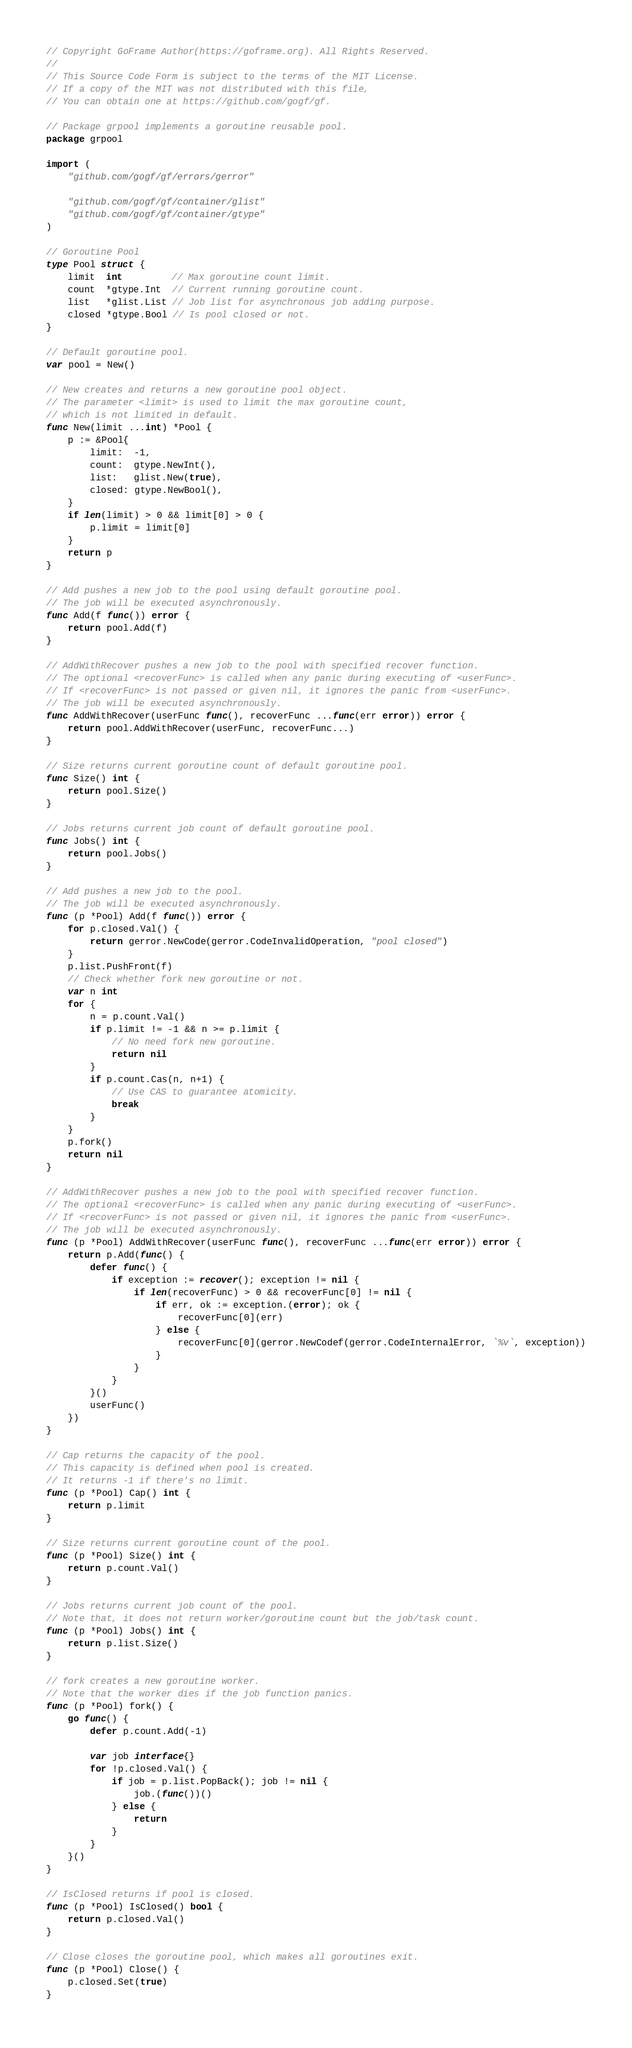Convert code to text. <code><loc_0><loc_0><loc_500><loc_500><_Go_>// Copyright GoFrame Author(https://goframe.org). All Rights Reserved.
//
// This Source Code Form is subject to the terms of the MIT License.
// If a copy of the MIT was not distributed with this file,
// You can obtain one at https://github.com/gogf/gf.

// Package grpool implements a goroutine reusable pool.
package grpool

import (
	"github.com/gogf/gf/errors/gerror"

	"github.com/gogf/gf/container/glist"
	"github.com/gogf/gf/container/gtype"
)

// Goroutine Pool
type Pool struct {
	limit  int         // Max goroutine count limit.
	count  *gtype.Int  // Current running goroutine count.
	list   *glist.List // Job list for asynchronous job adding purpose.
	closed *gtype.Bool // Is pool closed or not.
}

// Default goroutine pool.
var pool = New()

// New creates and returns a new goroutine pool object.
// The parameter <limit> is used to limit the max goroutine count,
// which is not limited in default.
func New(limit ...int) *Pool {
	p := &Pool{
		limit:  -1,
		count:  gtype.NewInt(),
		list:   glist.New(true),
		closed: gtype.NewBool(),
	}
	if len(limit) > 0 && limit[0] > 0 {
		p.limit = limit[0]
	}
	return p
}

// Add pushes a new job to the pool using default goroutine pool.
// The job will be executed asynchronously.
func Add(f func()) error {
	return pool.Add(f)
}

// AddWithRecover pushes a new job to the pool with specified recover function.
// The optional <recoverFunc> is called when any panic during executing of <userFunc>.
// If <recoverFunc> is not passed or given nil, it ignores the panic from <userFunc>.
// The job will be executed asynchronously.
func AddWithRecover(userFunc func(), recoverFunc ...func(err error)) error {
	return pool.AddWithRecover(userFunc, recoverFunc...)
}

// Size returns current goroutine count of default goroutine pool.
func Size() int {
	return pool.Size()
}

// Jobs returns current job count of default goroutine pool.
func Jobs() int {
	return pool.Jobs()
}

// Add pushes a new job to the pool.
// The job will be executed asynchronously.
func (p *Pool) Add(f func()) error {
	for p.closed.Val() {
		return gerror.NewCode(gerror.CodeInvalidOperation, "pool closed")
	}
	p.list.PushFront(f)
	// Check whether fork new goroutine or not.
	var n int
	for {
		n = p.count.Val()
		if p.limit != -1 && n >= p.limit {
			// No need fork new goroutine.
			return nil
		}
		if p.count.Cas(n, n+1) {
			// Use CAS to guarantee atomicity.
			break
		}
	}
	p.fork()
	return nil
}

// AddWithRecover pushes a new job to the pool with specified recover function.
// The optional <recoverFunc> is called when any panic during executing of <userFunc>.
// If <recoverFunc> is not passed or given nil, it ignores the panic from <userFunc>.
// The job will be executed asynchronously.
func (p *Pool) AddWithRecover(userFunc func(), recoverFunc ...func(err error)) error {
	return p.Add(func() {
		defer func() {
			if exception := recover(); exception != nil {
				if len(recoverFunc) > 0 && recoverFunc[0] != nil {
					if err, ok := exception.(error); ok {
						recoverFunc[0](err)
					} else {
						recoverFunc[0](gerror.NewCodef(gerror.CodeInternalError, `%v`, exception))
					}
				}
			}
		}()
		userFunc()
	})
}

// Cap returns the capacity of the pool.
// This capacity is defined when pool is created.
// It returns -1 if there's no limit.
func (p *Pool) Cap() int {
	return p.limit
}

// Size returns current goroutine count of the pool.
func (p *Pool) Size() int {
	return p.count.Val()
}

// Jobs returns current job count of the pool.
// Note that, it does not return worker/goroutine count but the job/task count.
func (p *Pool) Jobs() int {
	return p.list.Size()
}

// fork creates a new goroutine worker.
// Note that the worker dies if the job function panics.
func (p *Pool) fork() {
	go func() {
		defer p.count.Add(-1)

		var job interface{}
		for !p.closed.Val() {
			if job = p.list.PopBack(); job != nil {
				job.(func())()
			} else {
				return
			}
		}
	}()
}

// IsClosed returns if pool is closed.
func (p *Pool) IsClosed() bool {
	return p.closed.Val()
}

// Close closes the goroutine pool, which makes all goroutines exit.
func (p *Pool) Close() {
	p.closed.Set(true)
}
</code> 